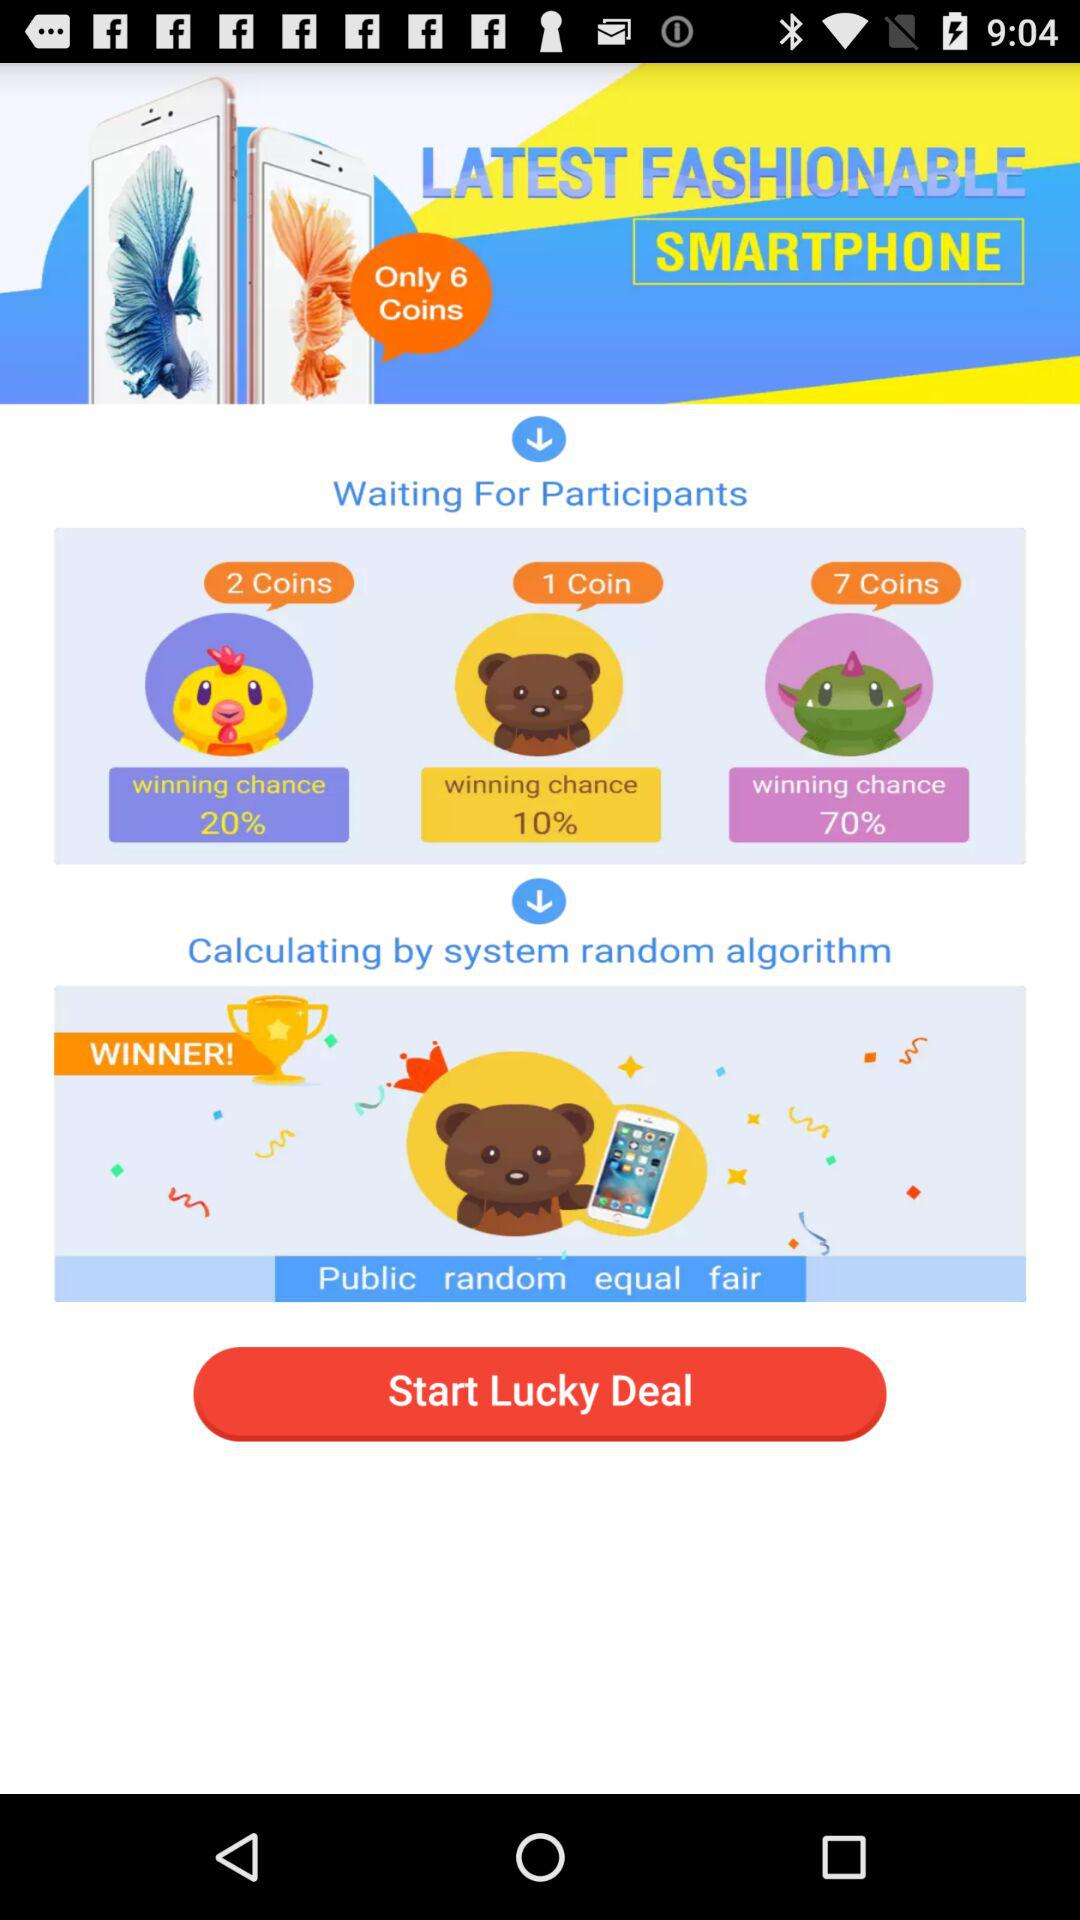How many coins are required for the highest winning chance?
Answer the question using a single word or phrase. 7 